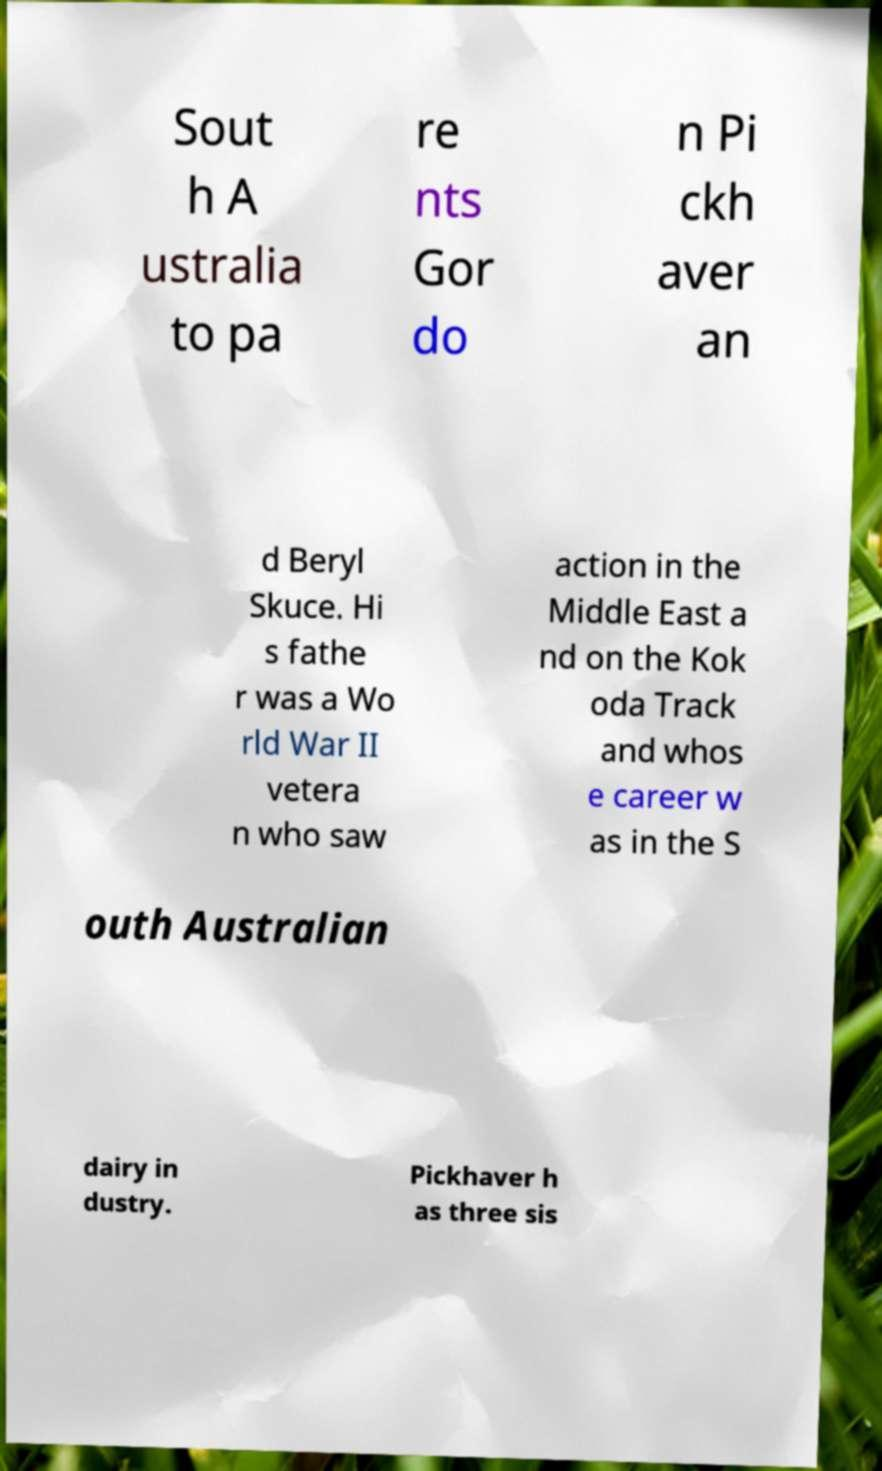Could you assist in decoding the text presented in this image and type it out clearly? Sout h A ustralia to pa re nts Gor do n Pi ckh aver an d Beryl Skuce. Hi s fathe r was a Wo rld War II vetera n who saw action in the Middle East a nd on the Kok oda Track and whos e career w as in the S outh Australian dairy in dustry. Pickhaver h as three sis 